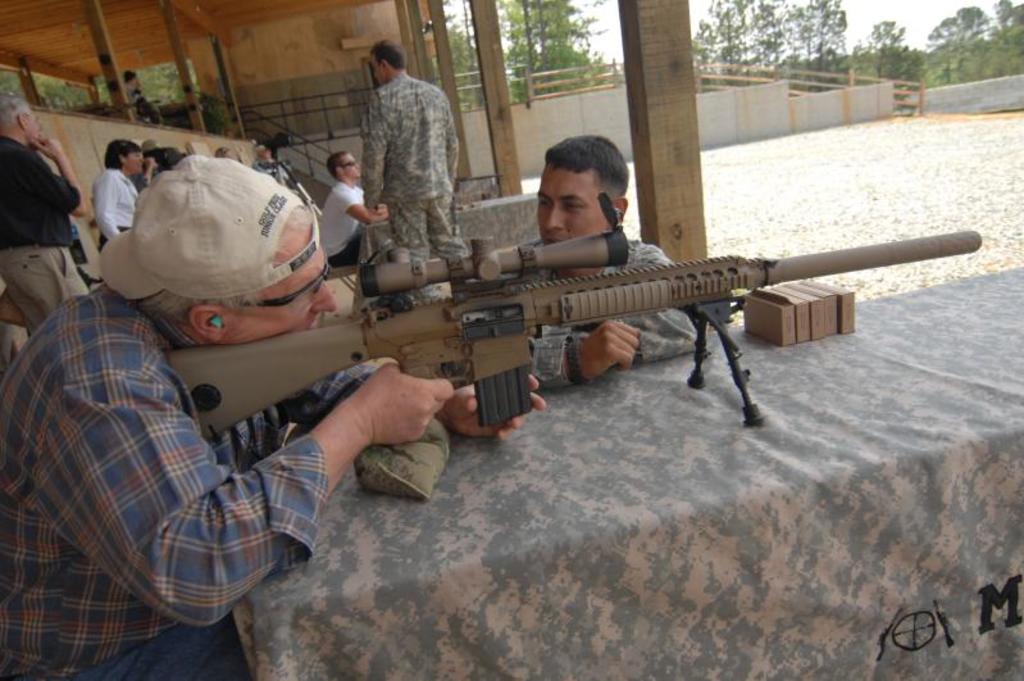Could you give a brief overview of what you see in this image? In this image I can see number of people where in the front I can see one of them is holding a gun, I can see he is wearing shirt, shooting goggles and a cap. I can also see two men are wearing uniforms. In the background I can see number of wooden poles, railings, the wall, number of trees and the sky. I can also see few camouflage colour clothes in the centre of the image and on the bottom right side of this image I can see something is written on the cloth. 